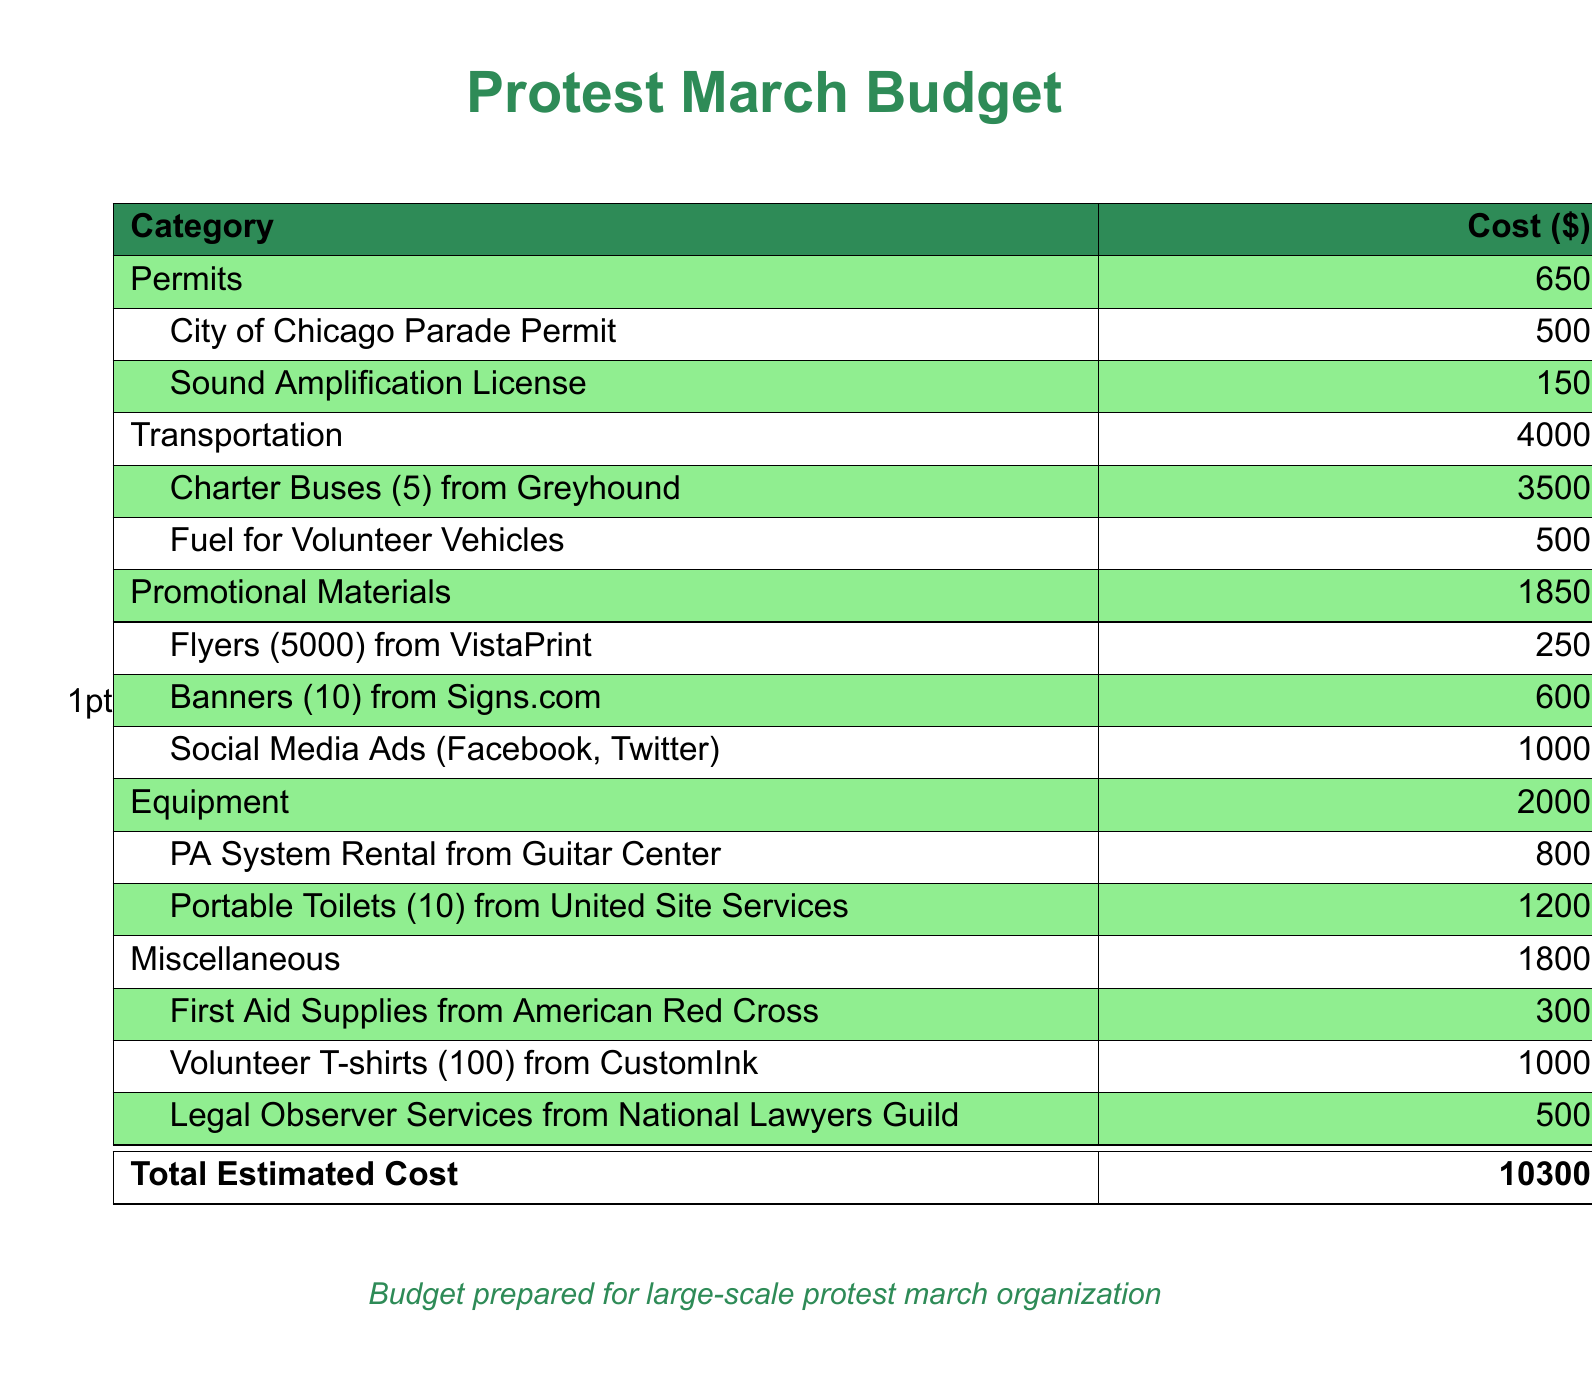What is the total estimated cost for the protest march? The total estimated cost is provided in the document as the sum of all categories.
Answer: 10300 How much is allocated for promotional materials? The budget specifies the allocation for promotional materials, which includes various items.
Answer: 1850 What is the cost of the City of Chicago Parade Permit? The specific cost for the permit is listed under the permits category.
Answer: 500 How many charter buses are included in the transportation costs? The budget indicates the number of charter buses rented for the event.
Answer: 5 What amount is designated for fuel for volunteer vehicles? The document details the fuel expenses for volunteer transport.
Answer: 500 Which company provides the PA system rental? The document states the company responsible for renting the PA system.
Answer: Guitar Center What category has the highest cost? By comparing all the expense categories, we determine which has the highest allocation.
Answer: Transportation How many first aid supplies are budgeted from the American Red Cross? This specifies the corresponding expenses for first aid supplies included in the miscellaneous category.
Answer: 300 What is the cost for legal observer services? The document lists the expense for legal observer services in the miscellaneous section.
Answer: 500 